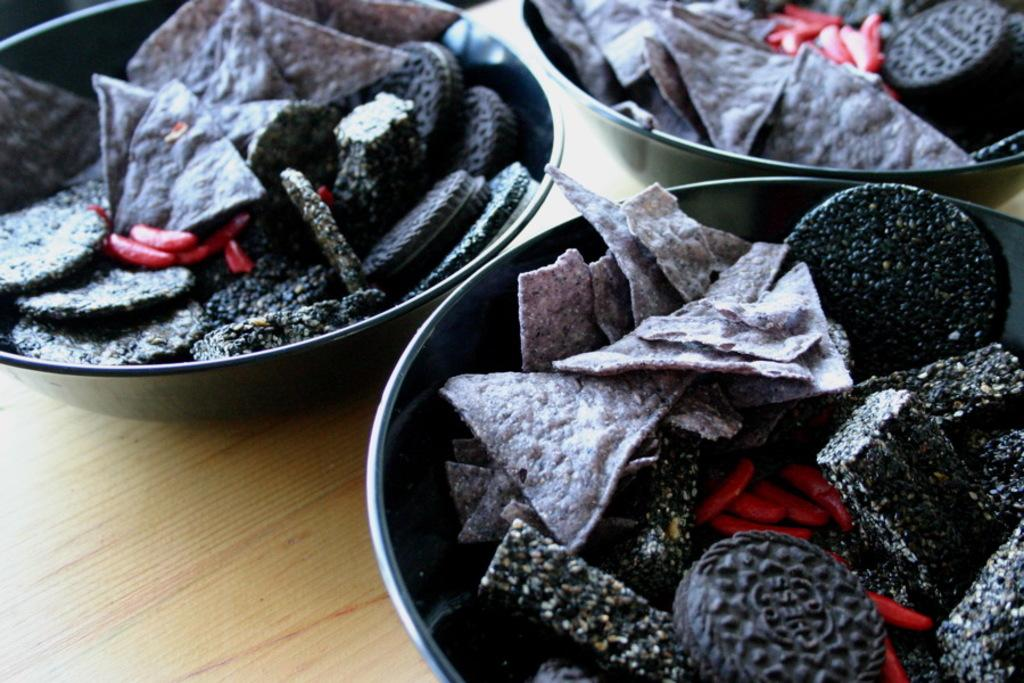What is on the plates that are visible in the image? There are plates with food in the image. What type of surface is the food placed on? The plates are on a wooden table. What type of division can be seen between the plates in the image? There is no division between the plates in the image; they are simply placed on the wooden table. 